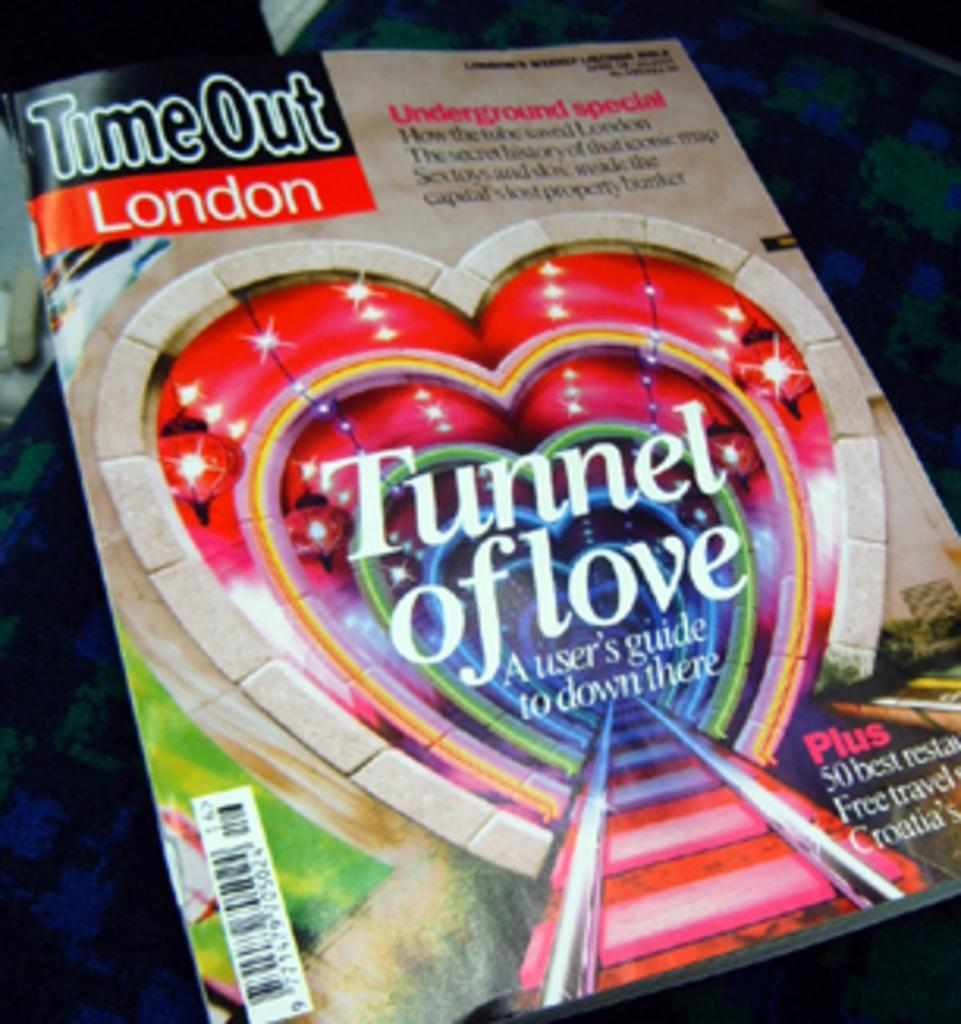<image>
Create a compact narrative representing the image presented. A book titled Tunnel of Love has a heart on the cover. 